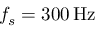<formula> <loc_0><loc_0><loc_500><loc_500>f _ { s } = 3 0 0 \, H z</formula> 